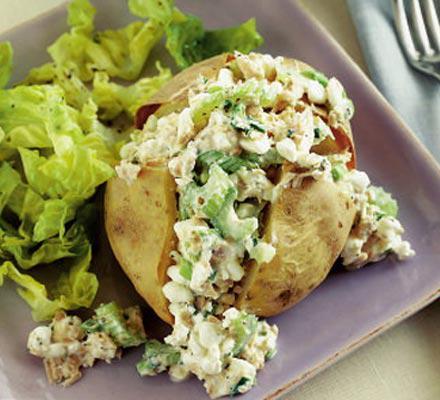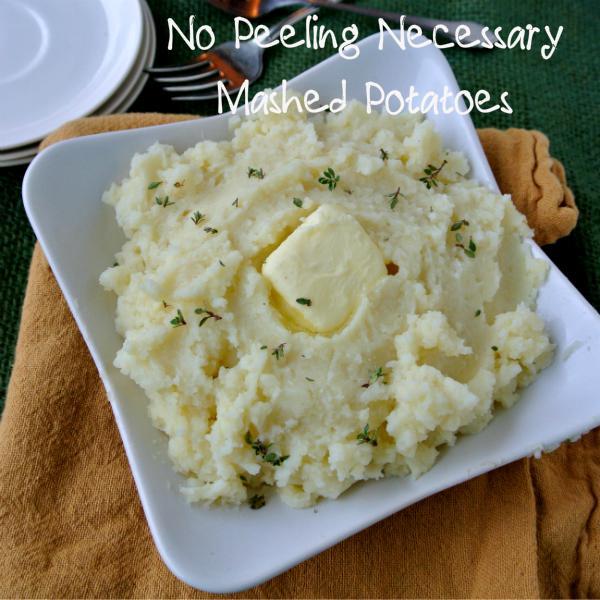The first image is the image on the left, the second image is the image on the right. Considering the images on both sides, is "One image shows mashed potatoes in a squared white dish, with no other food served on the same dish." valid? Answer yes or no. Yes. The first image is the image on the left, the second image is the image on the right. Analyze the images presented: Is the assertion "One of the images shows  a bowl of mashed potatoes with a spoon in it." valid? Answer yes or no. No. 